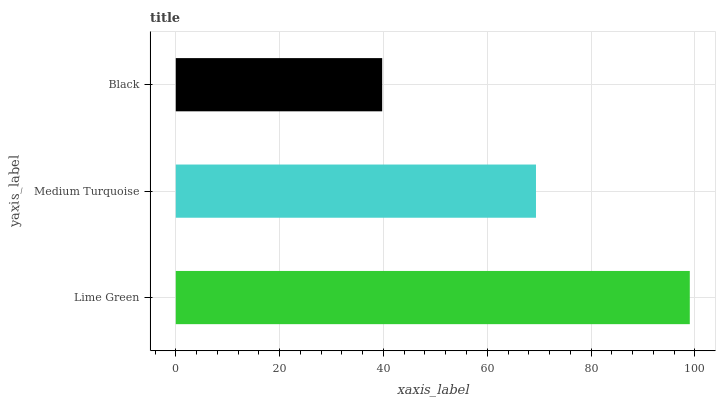Is Black the minimum?
Answer yes or no. Yes. Is Lime Green the maximum?
Answer yes or no. Yes. Is Medium Turquoise the minimum?
Answer yes or no. No. Is Medium Turquoise the maximum?
Answer yes or no. No. Is Lime Green greater than Medium Turquoise?
Answer yes or no. Yes. Is Medium Turquoise less than Lime Green?
Answer yes or no. Yes. Is Medium Turquoise greater than Lime Green?
Answer yes or no. No. Is Lime Green less than Medium Turquoise?
Answer yes or no. No. Is Medium Turquoise the high median?
Answer yes or no. Yes. Is Medium Turquoise the low median?
Answer yes or no. Yes. Is Black the high median?
Answer yes or no. No. Is Lime Green the low median?
Answer yes or no. No. 